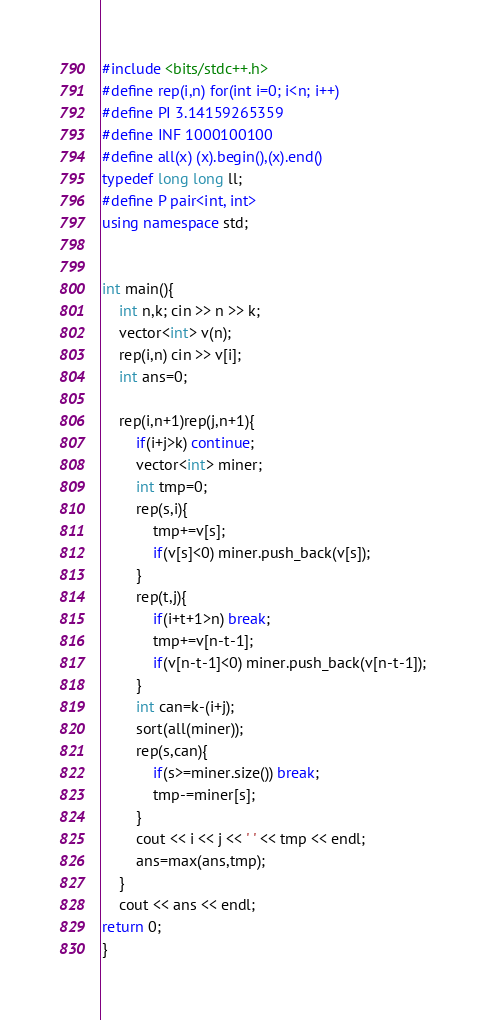Convert code to text. <code><loc_0><loc_0><loc_500><loc_500><_C++_>#include <bits/stdc++.h>
#define rep(i,n) for(int i=0; i<n; i++)
#define PI 3.14159265359
#define INF 1000100100
#define all(x) (x).begin(),(x).end()
typedef long long ll;
#define P pair<int, int>
using namespace std;
 
 
int main(){
    int n,k; cin >> n >> k;
    vector<int> v(n);
    rep(i,n) cin >> v[i];
    int ans=0;

    rep(i,n+1)rep(j,n+1){
        if(i+j>k) continue;
        vector<int> miner;
        int tmp=0;
        rep(s,i){
            tmp+=v[s];
            if(v[s]<0) miner.push_back(v[s]);
        }
        rep(t,j){
            if(i+t+1>n) break;
            tmp+=v[n-t-1];
            if(v[n-t-1]<0) miner.push_back(v[n-t-1]);
        }
        int can=k-(i+j);
        sort(all(miner));
        rep(s,can){
            if(s>=miner.size()) break;
            tmp-=miner[s];
        }
        cout << i << j << ' ' << tmp << endl;
        ans=max(ans,tmp);
    }
    cout << ans << endl;
return 0;
}</code> 